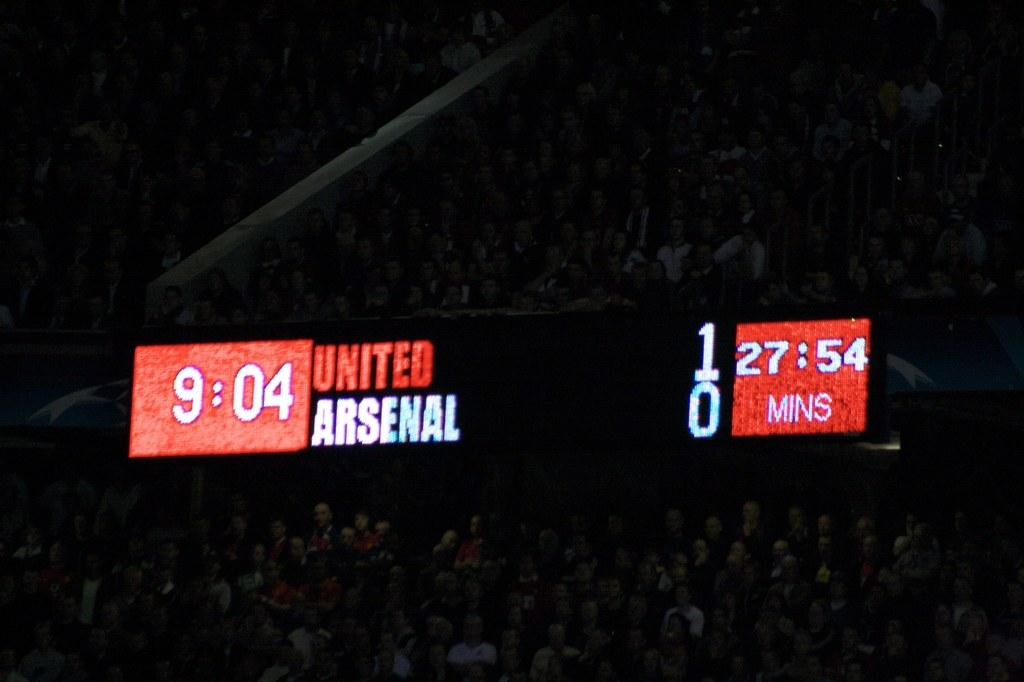What can be seen in the image related to people? There are people sitting in stands in the image. What is displayed on the screen in the image? There is a screen with some text visible in the image. Can you see any snakes slithering on the screen in the image? There are no snakes visible in the image, and the screen displays text rather than images. 